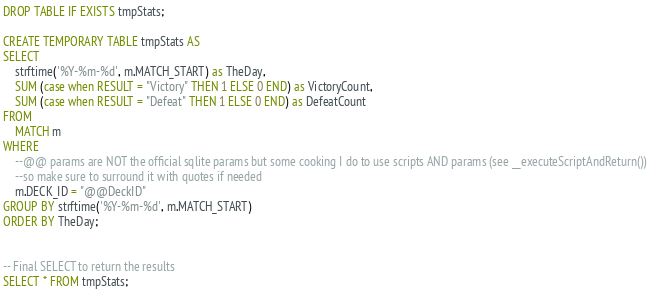Convert code to text. <code><loc_0><loc_0><loc_500><loc_500><_SQL_>DROP TABLE IF EXISTS tmpStats;

CREATE TEMPORARY TABLE tmpStats AS
SELECT 
	strftime('%Y-%m-%d', m.MATCH_START) as TheDay, 
	SUM (case when RESULT = "Victory" THEN 1 ELSE 0 END) as VictoryCount, 
	SUM (case when RESULT = "Defeat" THEN 1 ELSE 0 END) as DefeatCount
FROM
	MATCH m
WHERE 
    --@@ params are NOT the official sqlite params but some cooking I do to use scripts AND params (see __executeScriptAndReturn())
    --so make sure to surround it with quotes if needed
	m.DECK_ID = "@@DeckID"
GROUP BY strftime('%Y-%m-%d', m.MATCH_START)
ORDER BY TheDay;


-- Final SELECT to return the results
SELECT * FROM tmpStats;
</code> 